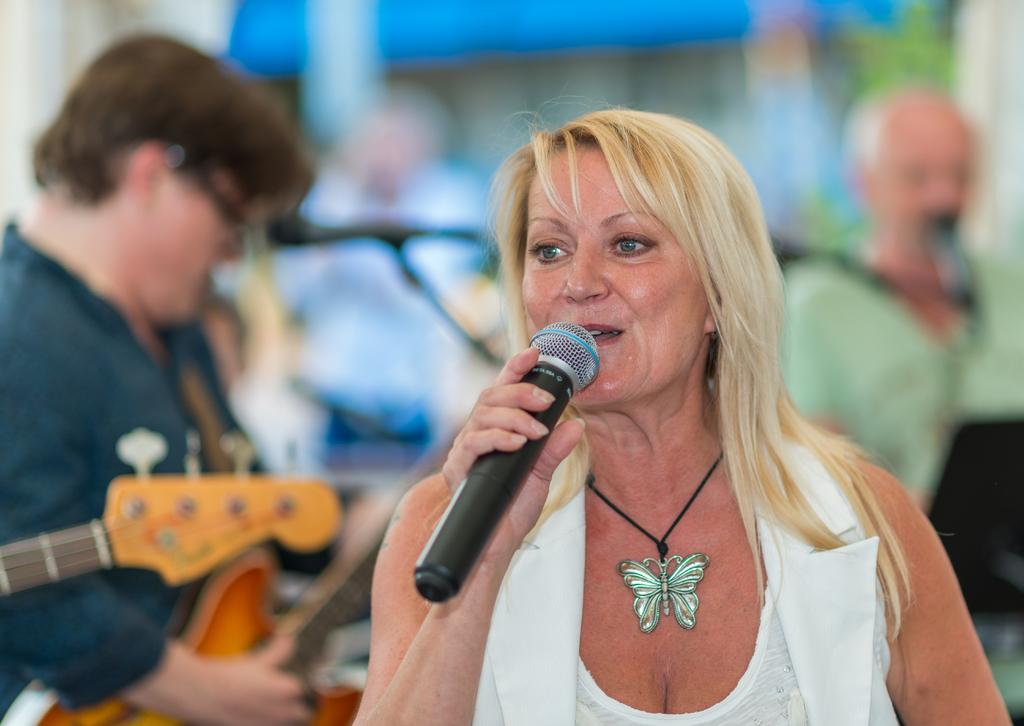What is happening in the image involving the group of people? There is a woman holding a mic in the front and singing, while a man is holding a guitar in the background and playing it. Can you describe the woman's role in the image? The woman is holding a mic and singing in the front. What is the man doing in the background? The man is holding a guitar and playing it in the background. What type of chalk is the stranger using to draw on the wall in the image? There is no stranger or chalk present in the image. 